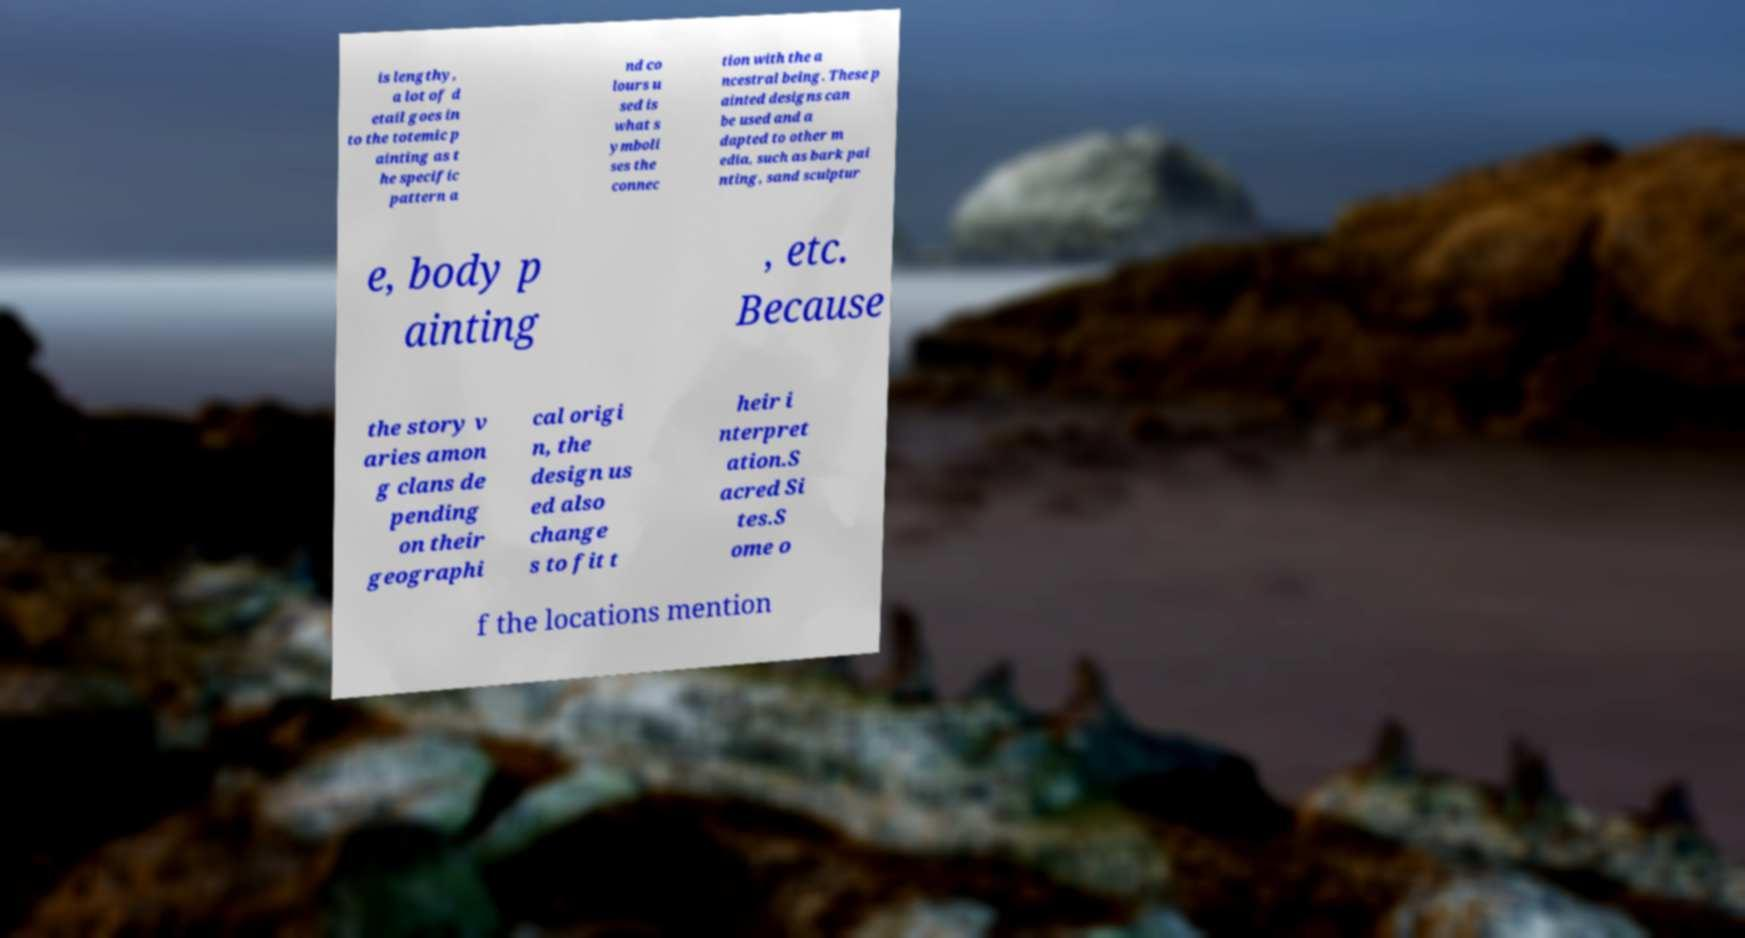I need the written content from this picture converted into text. Can you do that? is lengthy, a lot of d etail goes in to the totemic p ainting as t he specific pattern a nd co lours u sed is what s ymboli ses the connec tion with the a ncestral being. These p ainted designs can be used and a dapted to other m edia, such as bark pai nting, sand sculptur e, body p ainting , etc. Because the story v aries amon g clans de pending on their geographi cal origi n, the design us ed also change s to fit t heir i nterpret ation.S acred Si tes.S ome o f the locations mention 